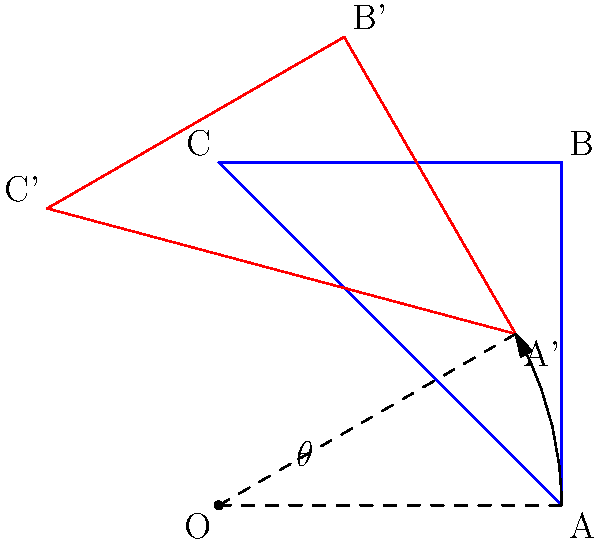In aligning our 2D ecosystem map with geographical coordinates, we need to rotate the map by $\theta$ degrees counterclockwise. If point A on the original map has coordinates (2,0), what are the coordinates of A' on the rotated map when $\theta = 30°$? To find the coordinates of A' after rotation, we can use the rotation matrix:

1. The rotation matrix for a counterclockwise rotation by $\theta$ is:
   $$\begin{pmatrix} \cos\theta & -\sin\theta \\ \sin\theta & \cos\theta \end{pmatrix}$$

2. We multiply this matrix by the original coordinates of A (2,0):
   $$\begin{pmatrix} \cos30° & -\sin30° \\ \sin30° & \cos30° \end{pmatrix} \begin{pmatrix} 2 \\ 0 \end{pmatrix}$$

3. Simplify:
   $$\begin{pmatrix} 2\cos30° \\ 2\sin30° \end{pmatrix}$$

4. Calculate:
   $\cos30° = \frac{\sqrt{3}}{2}$ and $\sin30° = \frac{1}{2}$

5. Therefore:
   $$\begin{pmatrix} 2 \cdot \frac{\sqrt{3}}{2} \\ 2 \cdot \frac{1}{2} \end{pmatrix} = \begin{pmatrix} \sqrt{3} \\ 1 \end{pmatrix}$$

Thus, the coordinates of A' are $(\sqrt{3}, 1)$.
Answer: $(\sqrt{3}, 1)$ 